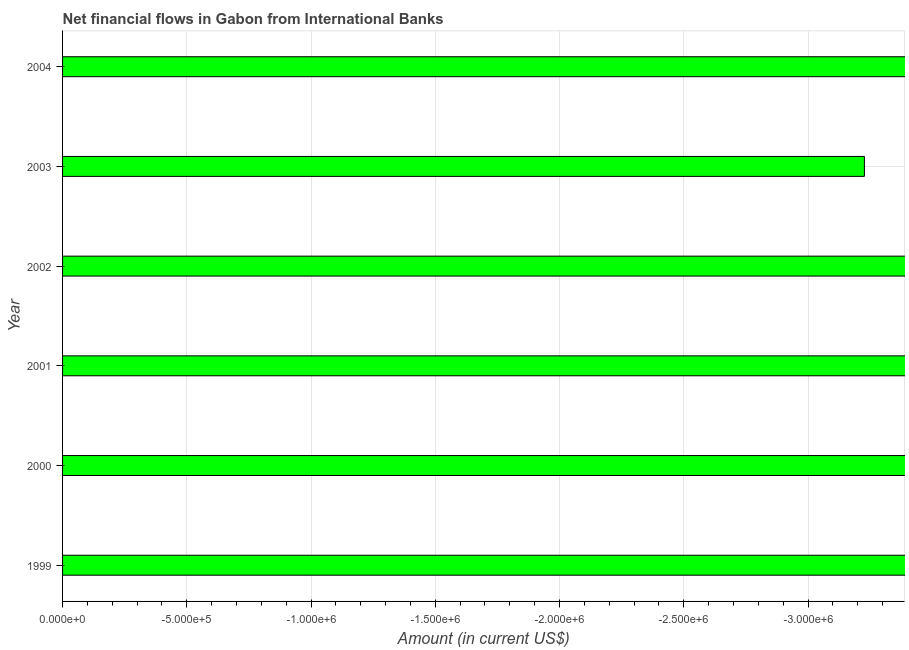What is the title of the graph?
Give a very brief answer. Net financial flows in Gabon from International Banks. What is the label or title of the X-axis?
Your response must be concise. Amount (in current US$). What is the net financial flows from ibrd in 2003?
Give a very brief answer. 0. What is the sum of the net financial flows from ibrd?
Provide a short and direct response. 0. What is the average net financial flows from ibrd per year?
Your response must be concise. 0. Are all the bars in the graph horizontal?
Your answer should be compact. Yes. Are the values on the major ticks of X-axis written in scientific E-notation?
Provide a succinct answer. Yes. What is the Amount (in current US$) in 2000?
Offer a terse response. 0. What is the Amount (in current US$) in 2001?
Your answer should be very brief. 0. What is the Amount (in current US$) in 2002?
Ensure brevity in your answer.  0. What is the Amount (in current US$) in 2003?
Ensure brevity in your answer.  0. 